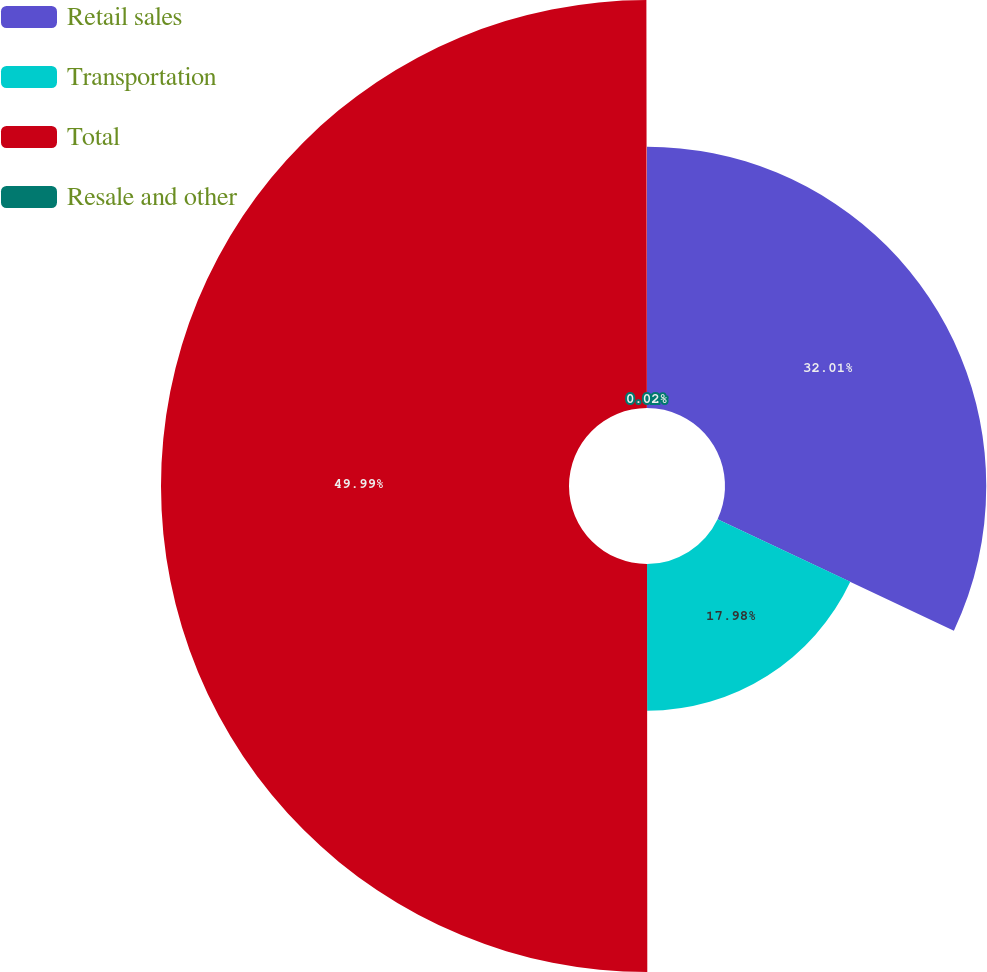Convert chart to OTSL. <chart><loc_0><loc_0><loc_500><loc_500><pie_chart><fcel>Retail sales<fcel>Transportation<fcel>Total<fcel>Resale and other<nl><fcel>32.01%<fcel>17.98%<fcel>49.99%<fcel>0.02%<nl></chart> 